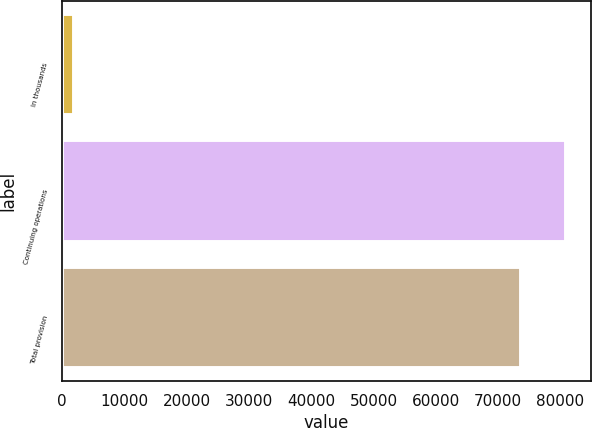Convert chart. <chart><loc_0><loc_0><loc_500><loc_500><bar_chart><fcel>In thousands<fcel>Continuing operations<fcel>Total provision<nl><fcel>2008<fcel>80918.8<fcel>73745<nl></chart> 